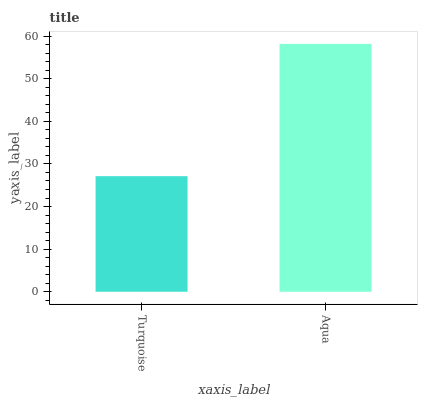Is Turquoise the minimum?
Answer yes or no. Yes. Is Aqua the maximum?
Answer yes or no. Yes. Is Aqua the minimum?
Answer yes or no. No. Is Aqua greater than Turquoise?
Answer yes or no. Yes. Is Turquoise less than Aqua?
Answer yes or no. Yes. Is Turquoise greater than Aqua?
Answer yes or no. No. Is Aqua less than Turquoise?
Answer yes or no. No. Is Aqua the high median?
Answer yes or no. Yes. Is Turquoise the low median?
Answer yes or no. Yes. Is Turquoise the high median?
Answer yes or no. No. Is Aqua the low median?
Answer yes or no. No. 